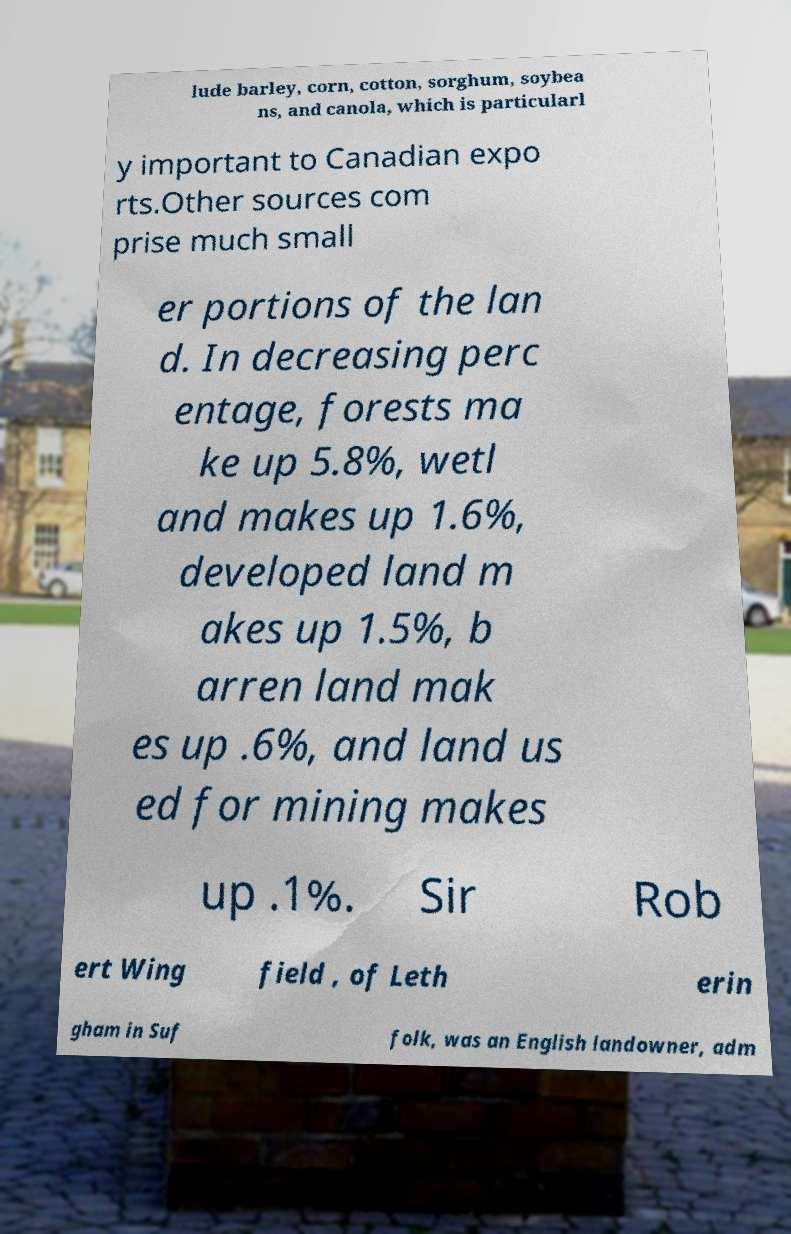What messages or text are displayed in this image? I need them in a readable, typed format. lude barley, corn, cotton, sorghum, soybea ns, and canola, which is particularl y important to Canadian expo rts.Other sources com prise much small er portions of the lan d. In decreasing perc entage, forests ma ke up 5.8%, wetl and makes up 1.6%, developed land m akes up 1.5%, b arren land mak es up .6%, and land us ed for mining makes up .1%. Sir Rob ert Wing field , of Leth erin gham in Suf folk, was an English landowner, adm 